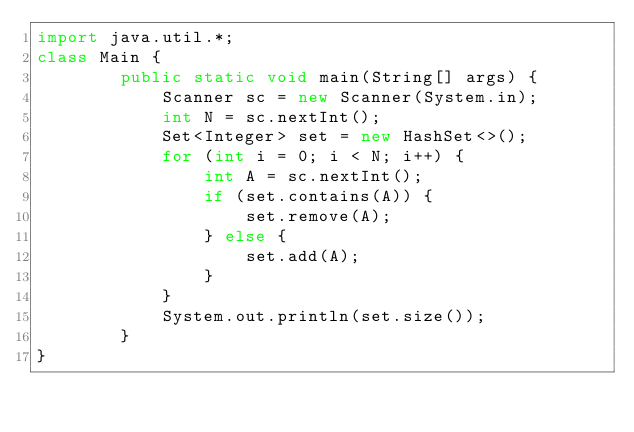<code> <loc_0><loc_0><loc_500><loc_500><_Java_>import java.util.*;
class Main {
		public static void main(String[] args) {
			Scanner sc = new Scanner(System.in);
			int N = sc.nextInt();
			Set<Integer> set = new HashSet<>();
			for (int i = 0; i < N; i++) {
				int A = sc.nextInt();
				if (set.contains(A)) {
					set.remove(A);
				} else {
					set.add(A);
				}
			}
			System.out.println(set.size());
		}
}</code> 